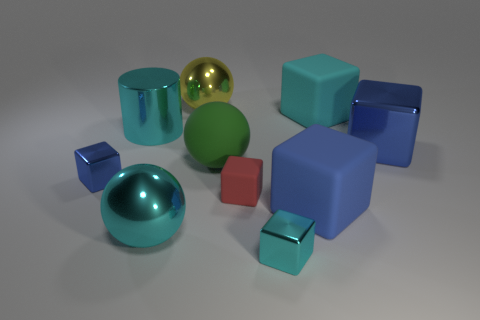Subtract all big green rubber balls. How many balls are left? 2 Subtract all red cubes. How many cubes are left? 5 Subtract all purple cylinders. How many blue cubes are left? 3 Subtract 2 spheres. How many spheres are left? 1 Subtract all spheres. How many objects are left? 7 Subtract all green cylinders. Subtract all gray blocks. How many cylinders are left? 1 Subtract all cylinders. Subtract all blue metallic blocks. How many objects are left? 7 Add 2 big cyan cylinders. How many big cyan cylinders are left? 3 Add 2 big cyan metal things. How many big cyan metal things exist? 4 Subtract 0 gray blocks. How many objects are left? 10 